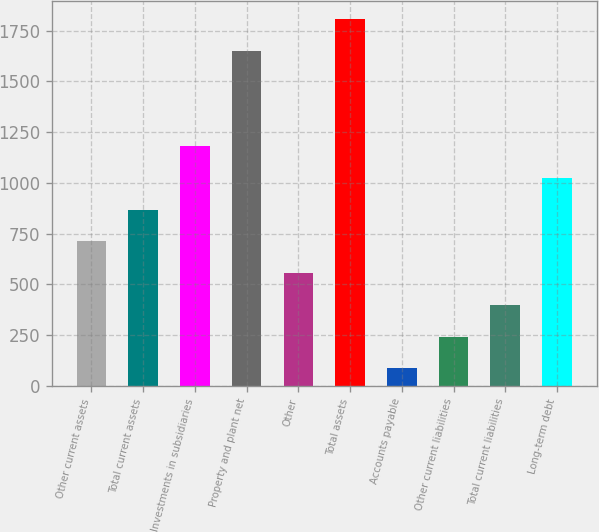<chart> <loc_0><loc_0><loc_500><loc_500><bar_chart><fcel>Other current assets<fcel>Total current assets<fcel>Investments in subsidiaries<fcel>Property and plant net<fcel>Other<fcel>Total assets<fcel>Accounts payable<fcel>Other current liabilities<fcel>Total current liabilities<fcel>Long-term debt<nl><fcel>711.2<fcel>867.5<fcel>1180.1<fcel>1649<fcel>554.9<fcel>1805.3<fcel>86<fcel>242.3<fcel>398.6<fcel>1023.8<nl></chart> 